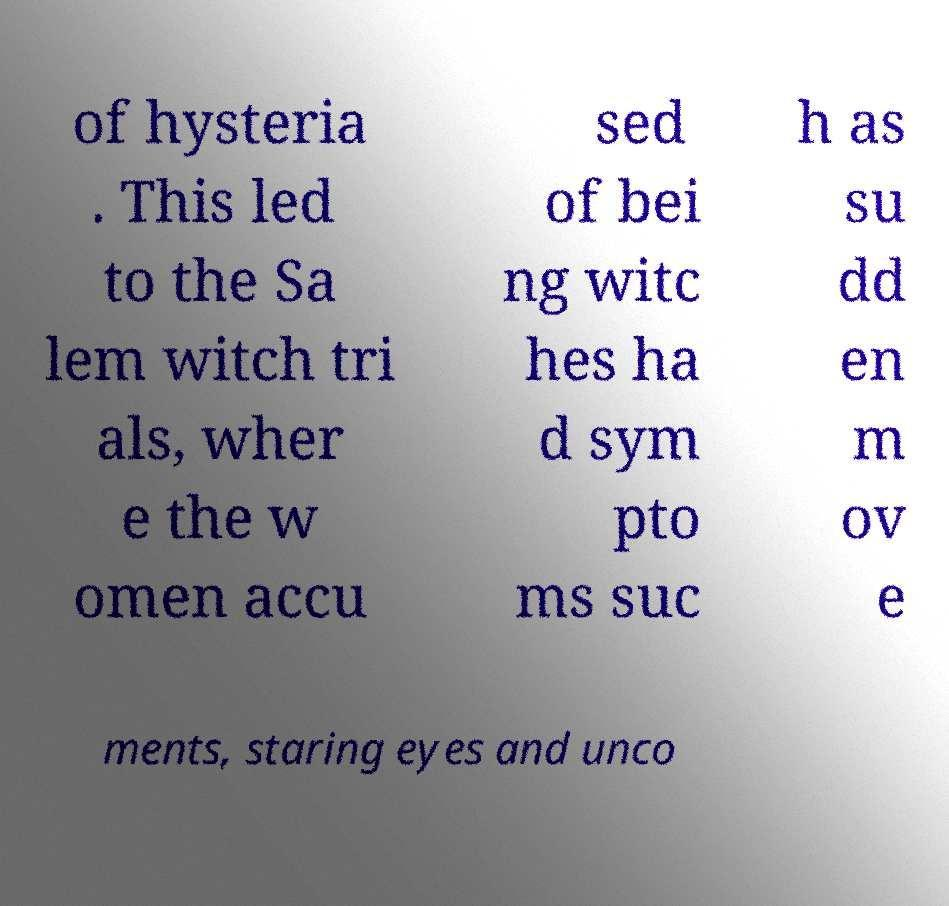Can you accurately transcribe the text from the provided image for me? of hysteria . This led to the Sa lem witch tri als, wher e the w omen accu sed of bei ng witc hes ha d sym pto ms suc h as su dd en m ov e ments, staring eyes and unco 